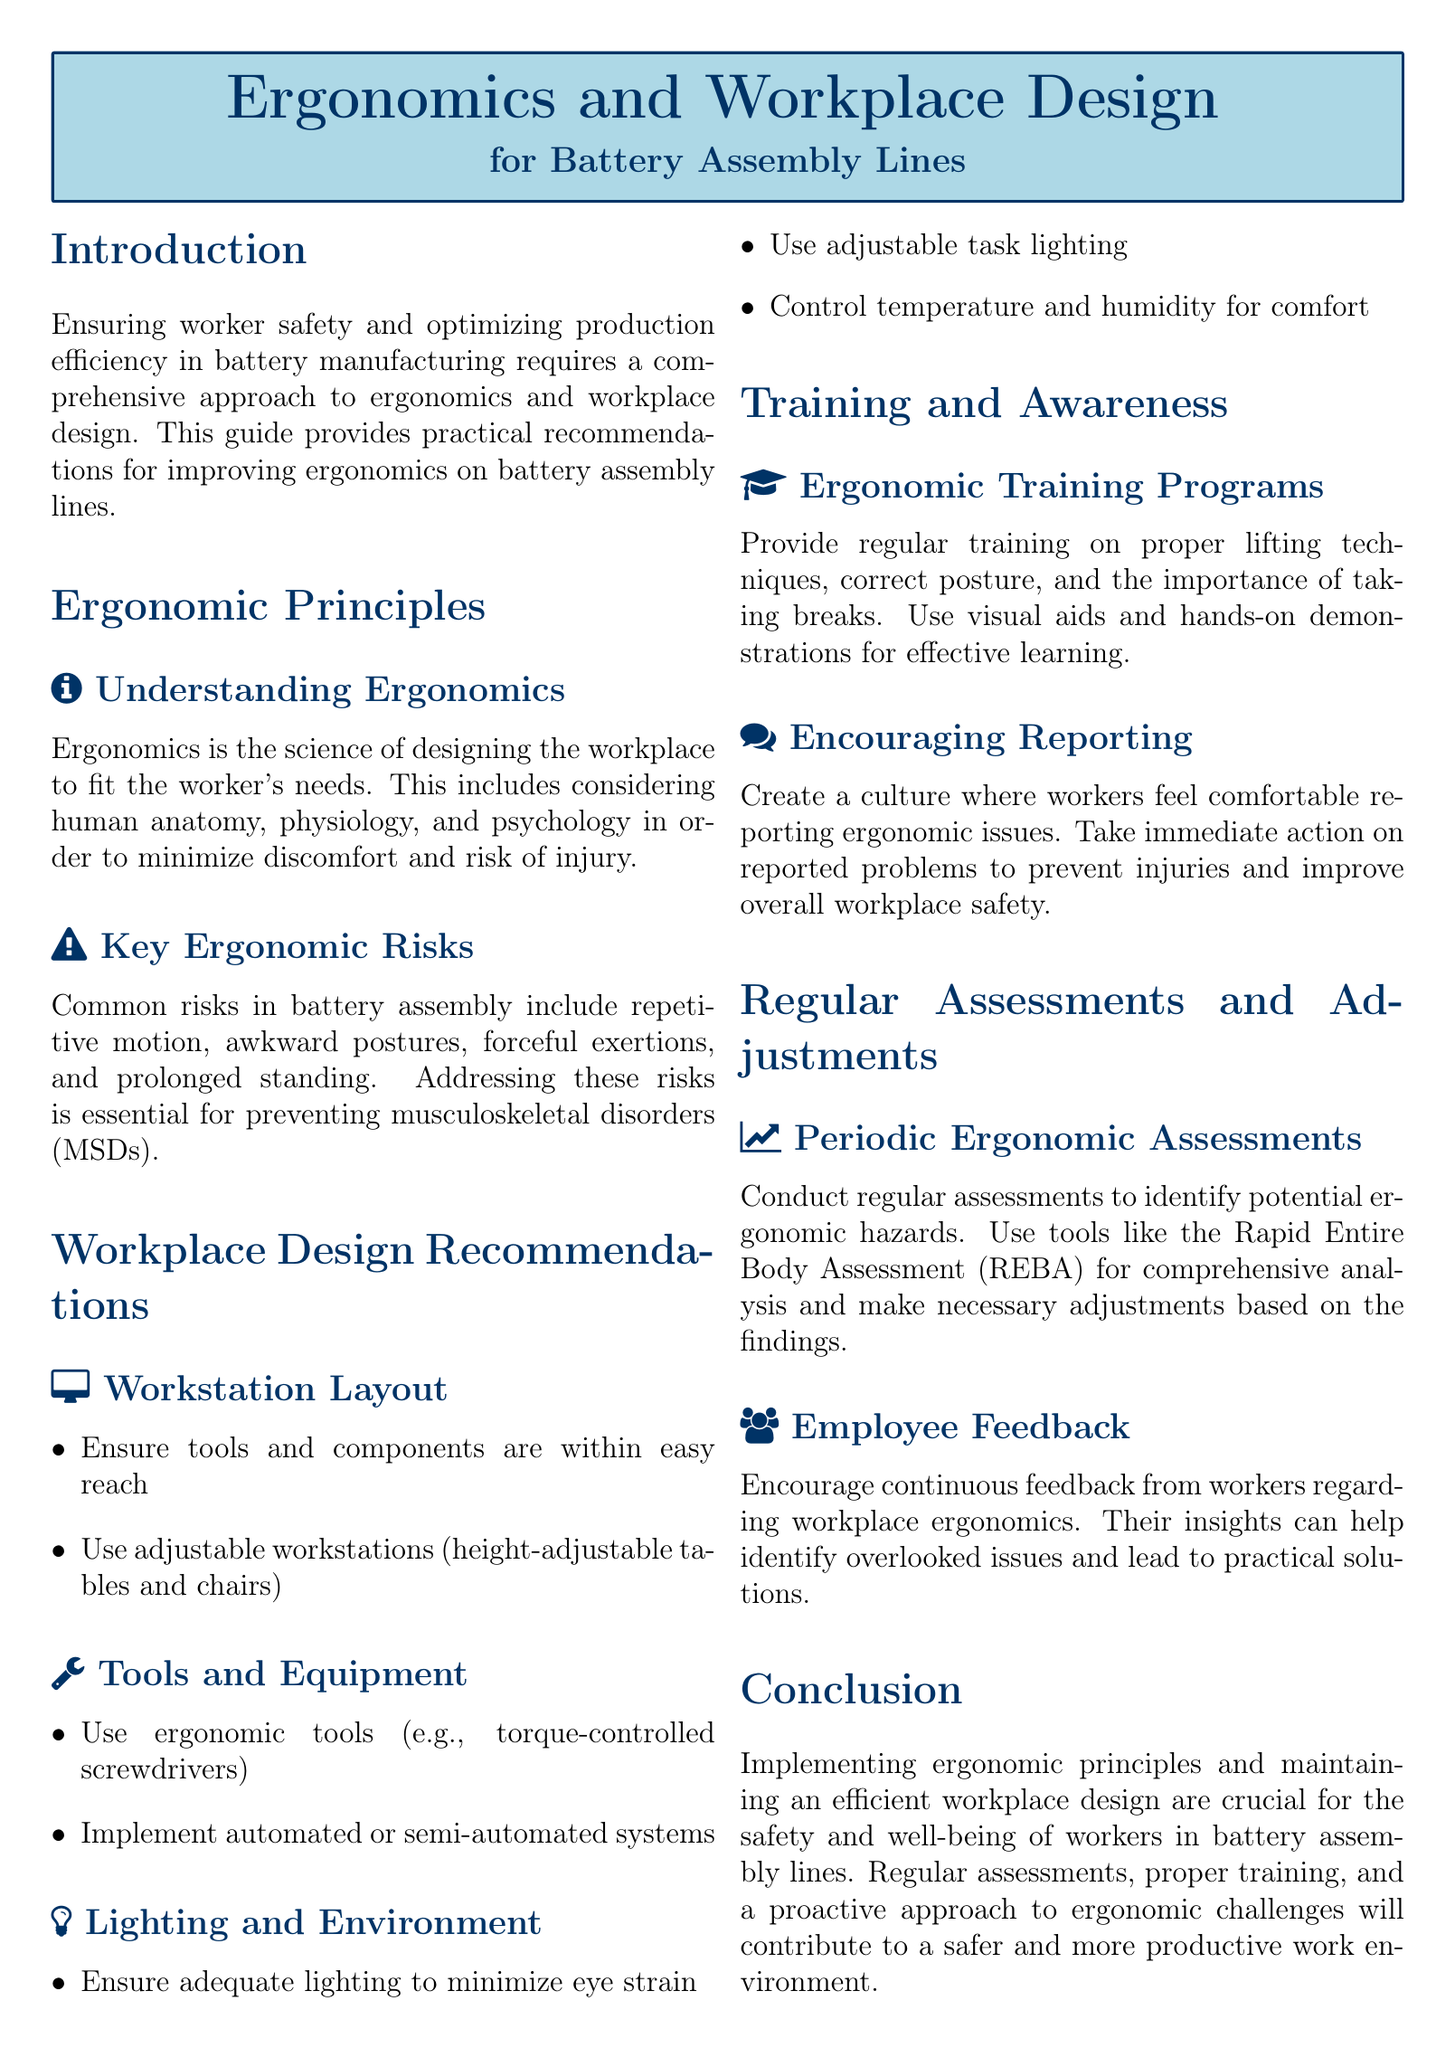What is the focus of this guide? The guide focuses on ensuring worker safety and optimizing production efficiency in battery manufacturing through ergonomics and workplace design.
Answer: Worker safety and production efficiency What are the common ergonomic risks in battery assembly? The document mentions repetitive motion, awkward postures, forceful exertions, and prolonged standing as common ergonomic risks.
Answer: Repetitive motion, awkward postures, forceful exertions, prolonged standing What should be included in workstation layout? The recommendations for workstation layout include ensuring tools and components are within easy reach and using adjustable workstations.
Answer: Easy reach and adjustable workstations What type of tools does the document suggest? The guide recommends using ergonomic tools, such as torque-controlled screwdrivers.
Answer: Torque-controlled screwdrivers How often should ergonomic assessments be conducted? The document states that periodic ergonomic assessments should be conducted regularly.
Answer: Regularly What is a key element for ergonomic training programs? Key elements for ergonomic training programs include proper lifting techniques, correct posture, and the importance of taking breaks.
Answer: Proper lifting techniques, correct posture, taking breaks What does the guide emphasize about employee feedback? The guide emphasizes that continuous feedback from workers regarding workplace ergonomics is important for identifying issues.
Answer: Continuous feedback What is one of the environmental factors that should be controlled? The document advises controlling temperature and humidity for worker comfort.
Answer: Temperature and humidity 